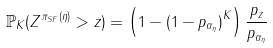<formula> <loc_0><loc_0><loc_500><loc_500>\mathbb { P } _ { K } ( Z ^ { \pi _ { S F } ( \eta ) } > z ) = \left ( 1 - { ( 1 - p _ { \alpha _ { \eta } } ) } ^ { K } \right ) \frac { p _ { z } } { p _ { \alpha _ { \eta } } }</formula> 